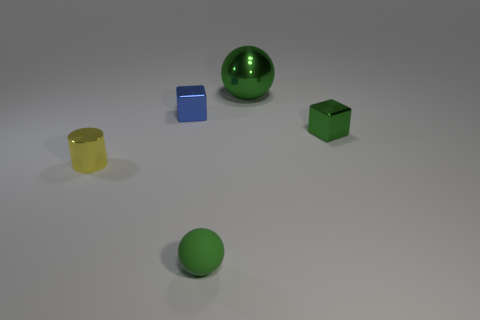Add 1 small blue shiny cubes. How many objects exist? 6 Subtract all cubes. How many objects are left? 3 Add 3 large balls. How many large balls exist? 4 Subtract 0 blue cylinders. How many objects are left? 5 Subtract all red things. Subtract all large spheres. How many objects are left? 4 Add 4 green objects. How many green objects are left? 7 